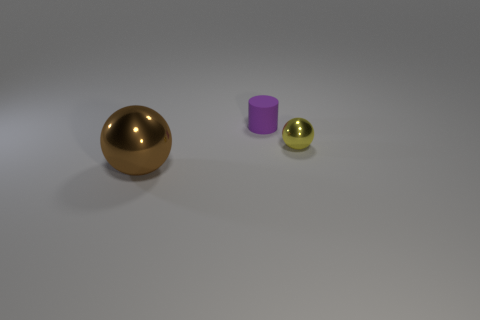Is there any other thing that has the same size as the brown ball?
Provide a succinct answer. No. What is the brown sphere made of?
Make the answer very short. Metal. What color is the thing that is the same material as the yellow sphere?
Your response must be concise. Brown. Are there any rubber objects right of the shiny object that is to the left of the small purple matte cylinder?
Give a very brief answer. Yes. How many other objects are there of the same shape as the purple rubber thing?
Ensure brevity in your answer.  0. There is a shiny object that is left of the purple matte thing; is its shape the same as the shiny object to the right of the large sphere?
Give a very brief answer. Yes. What number of things are in front of the tiny thing that is to the left of the shiny sphere that is behind the brown metallic ball?
Ensure brevity in your answer.  2. The small cylinder has what color?
Keep it short and to the point. Purple. How many other things are the same size as the brown object?
Give a very brief answer. 0. There is a tiny thing that is the same shape as the big object; what material is it?
Your answer should be very brief. Metal. 